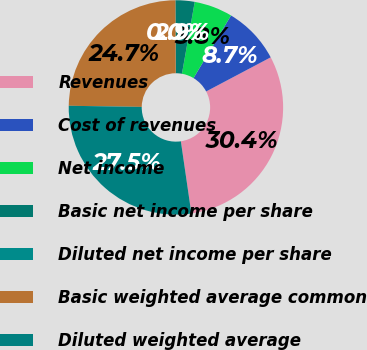<chart> <loc_0><loc_0><loc_500><loc_500><pie_chart><fcel>Revenues<fcel>Cost of revenues<fcel>Net income<fcel>Basic net income per share<fcel>Diluted net income per share<fcel>Basic weighted average common<fcel>Diluted weighted average<nl><fcel>30.44%<fcel>8.67%<fcel>5.78%<fcel>2.89%<fcel>0.0%<fcel>24.67%<fcel>27.55%<nl></chart> 